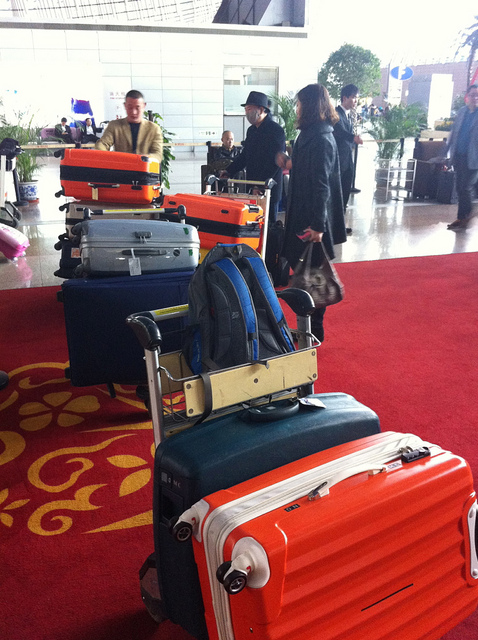How many umbrellas are in the photo? There are no umbrellas visible in the photo. The image depicts a scene with luggage, likely at an airport or a similar travel hub, but no umbrellas can be seen. 